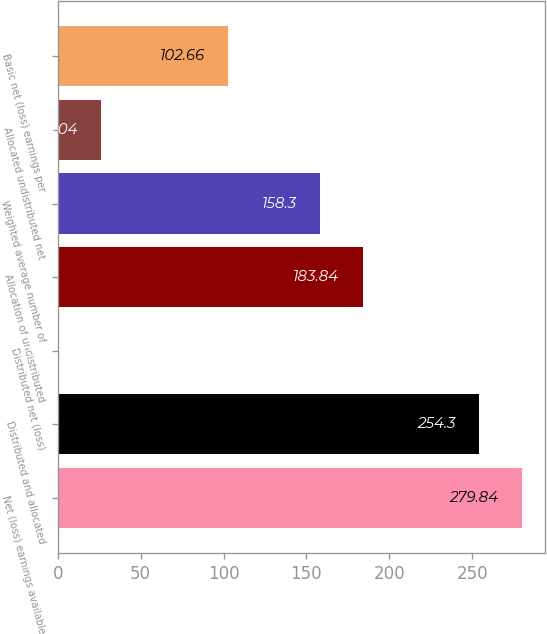Convert chart to OTSL. <chart><loc_0><loc_0><loc_500><loc_500><bar_chart><fcel>Net (loss) earnings available<fcel>Distributed and allocated<fcel>Distributed net (loss)<fcel>Allocation of undistributed<fcel>Weighted average number of<fcel>Allocated undistributed net<fcel>Basic net (loss) earnings per<nl><fcel>279.84<fcel>254.3<fcel>0.5<fcel>183.84<fcel>158.3<fcel>26.04<fcel>102.66<nl></chart> 